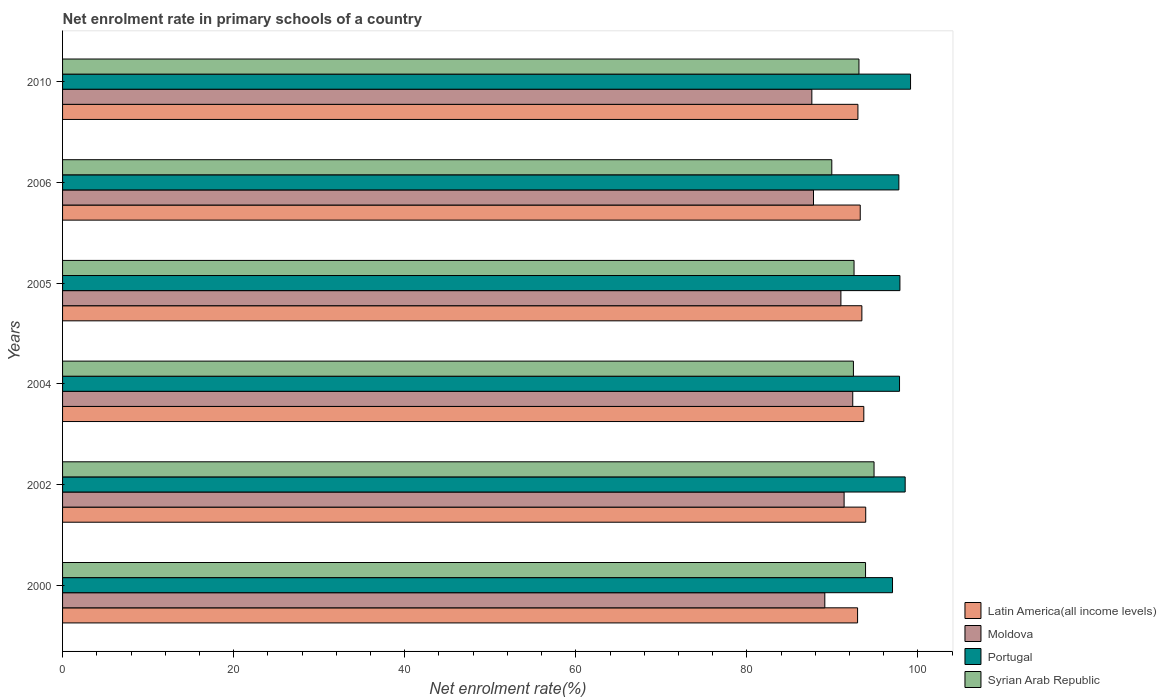Are the number of bars on each tick of the Y-axis equal?
Your response must be concise. Yes. How many bars are there on the 6th tick from the top?
Make the answer very short. 4. In how many cases, is the number of bars for a given year not equal to the number of legend labels?
Give a very brief answer. 0. What is the net enrolment rate in primary schools in Latin America(all income levels) in 2010?
Offer a very short reply. 92.98. Across all years, what is the maximum net enrolment rate in primary schools in Portugal?
Your answer should be very brief. 99.13. Across all years, what is the minimum net enrolment rate in primary schools in Portugal?
Your answer should be compact. 97.02. What is the total net enrolment rate in primary schools in Latin America(all income levels) in the graph?
Keep it short and to the point. 560.16. What is the difference between the net enrolment rate in primary schools in Portugal in 2002 and that in 2004?
Offer a very short reply. 0.66. What is the difference between the net enrolment rate in primary schools in Moldova in 2010 and the net enrolment rate in primary schools in Syrian Arab Republic in 2000?
Ensure brevity in your answer.  -6.28. What is the average net enrolment rate in primary schools in Portugal per year?
Give a very brief answer. 98.02. In the year 2000, what is the difference between the net enrolment rate in primary schools in Moldova and net enrolment rate in primary schools in Syrian Arab Republic?
Your answer should be very brief. -4.76. What is the ratio of the net enrolment rate in primary schools in Portugal in 2004 to that in 2010?
Provide a succinct answer. 0.99. Is the difference between the net enrolment rate in primary schools in Moldova in 2006 and 2010 greater than the difference between the net enrolment rate in primary schools in Syrian Arab Republic in 2006 and 2010?
Your answer should be very brief. Yes. What is the difference between the highest and the second highest net enrolment rate in primary schools in Latin America(all income levels)?
Provide a succinct answer. 0.22. What is the difference between the highest and the lowest net enrolment rate in primary schools in Latin America(all income levels)?
Provide a succinct answer. 0.95. In how many years, is the net enrolment rate in primary schools in Moldova greater than the average net enrolment rate in primary schools in Moldova taken over all years?
Ensure brevity in your answer.  3. What does the 4th bar from the top in 2004 represents?
Make the answer very short. Latin America(all income levels). What does the 2nd bar from the bottom in 2006 represents?
Give a very brief answer. Moldova. Is it the case that in every year, the sum of the net enrolment rate in primary schools in Portugal and net enrolment rate in primary schools in Syrian Arab Republic is greater than the net enrolment rate in primary schools in Moldova?
Provide a succinct answer. Yes. Are all the bars in the graph horizontal?
Give a very brief answer. Yes. How many years are there in the graph?
Offer a terse response. 6. What is the difference between two consecutive major ticks on the X-axis?
Your response must be concise. 20. Does the graph contain any zero values?
Provide a short and direct response. No. Does the graph contain grids?
Offer a very short reply. No. Where does the legend appear in the graph?
Offer a very short reply. Bottom right. How many legend labels are there?
Provide a succinct answer. 4. How are the legend labels stacked?
Offer a terse response. Vertical. What is the title of the graph?
Your response must be concise. Net enrolment rate in primary schools of a country. What is the label or title of the X-axis?
Offer a terse response. Net enrolment rate(%). What is the Net enrolment rate(%) of Latin America(all income levels) in 2000?
Keep it short and to the point. 92.94. What is the Net enrolment rate(%) of Moldova in 2000?
Your response must be concise. 89.11. What is the Net enrolment rate(%) in Portugal in 2000?
Offer a terse response. 97.02. What is the Net enrolment rate(%) of Syrian Arab Republic in 2000?
Offer a terse response. 93.87. What is the Net enrolment rate(%) in Latin America(all income levels) in 2002?
Your answer should be compact. 93.89. What is the Net enrolment rate(%) of Moldova in 2002?
Provide a succinct answer. 91.36. What is the Net enrolment rate(%) in Portugal in 2002?
Give a very brief answer. 98.5. What is the Net enrolment rate(%) in Syrian Arab Republic in 2002?
Your response must be concise. 94.86. What is the Net enrolment rate(%) of Latin America(all income levels) in 2004?
Make the answer very short. 93.67. What is the Net enrolment rate(%) in Moldova in 2004?
Keep it short and to the point. 92.37. What is the Net enrolment rate(%) of Portugal in 2004?
Ensure brevity in your answer.  97.84. What is the Net enrolment rate(%) in Syrian Arab Republic in 2004?
Your response must be concise. 92.45. What is the Net enrolment rate(%) of Latin America(all income levels) in 2005?
Your answer should be compact. 93.44. What is the Net enrolment rate(%) of Moldova in 2005?
Make the answer very short. 90.99. What is the Net enrolment rate(%) of Portugal in 2005?
Offer a terse response. 97.89. What is the Net enrolment rate(%) of Syrian Arab Republic in 2005?
Provide a succinct answer. 92.53. What is the Net enrolment rate(%) of Latin America(all income levels) in 2006?
Provide a short and direct response. 93.25. What is the Net enrolment rate(%) in Moldova in 2006?
Provide a succinct answer. 87.79. What is the Net enrolment rate(%) of Portugal in 2006?
Give a very brief answer. 97.76. What is the Net enrolment rate(%) of Syrian Arab Republic in 2006?
Make the answer very short. 89.92. What is the Net enrolment rate(%) of Latin America(all income levels) in 2010?
Your answer should be very brief. 92.98. What is the Net enrolment rate(%) in Moldova in 2010?
Provide a succinct answer. 87.59. What is the Net enrolment rate(%) of Portugal in 2010?
Your answer should be compact. 99.13. What is the Net enrolment rate(%) in Syrian Arab Republic in 2010?
Provide a succinct answer. 93.1. Across all years, what is the maximum Net enrolment rate(%) of Latin America(all income levels)?
Offer a very short reply. 93.89. Across all years, what is the maximum Net enrolment rate(%) in Moldova?
Your response must be concise. 92.37. Across all years, what is the maximum Net enrolment rate(%) in Portugal?
Provide a short and direct response. 99.13. Across all years, what is the maximum Net enrolment rate(%) of Syrian Arab Republic?
Provide a succinct answer. 94.86. Across all years, what is the minimum Net enrolment rate(%) in Latin America(all income levels)?
Offer a very short reply. 92.94. Across all years, what is the minimum Net enrolment rate(%) in Moldova?
Offer a very short reply. 87.59. Across all years, what is the minimum Net enrolment rate(%) of Portugal?
Ensure brevity in your answer.  97.02. Across all years, what is the minimum Net enrolment rate(%) in Syrian Arab Republic?
Provide a succinct answer. 89.92. What is the total Net enrolment rate(%) in Latin America(all income levels) in the graph?
Your response must be concise. 560.16. What is the total Net enrolment rate(%) in Moldova in the graph?
Keep it short and to the point. 539.21. What is the total Net enrolment rate(%) of Portugal in the graph?
Your answer should be very brief. 588.15. What is the total Net enrolment rate(%) of Syrian Arab Republic in the graph?
Your answer should be very brief. 556.73. What is the difference between the Net enrolment rate(%) of Latin America(all income levels) in 2000 and that in 2002?
Your answer should be compact. -0.95. What is the difference between the Net enrolment rate(%) in Moldova in 2000 and that in 2002?
Make the answer very short. -2.26. What is the difference between the Net enrolment rate(%) of Portugal in 2000 and that in 2002?
Provide a succinct answer. -1.48. What is the difference between the Net enrolment rate(%) of Syrian Arab Republic in 2000 and that in 2002?
Your answer should be compact. -0.99. What is the difference between the Net enrolment rate(%) in Latin America(all income levels) in 2000 and that in 2004?
Provide a short and direct response. -0.73. What is the difference between the Net enrolment rate(%) of Moldova in 2000 and that in 2004?
Provide a short and direct response. -3.27. What is the difference between the Net enrolment rate(%) of Portugal in 2000 and that in 2004?
Offer a terse response. -0.82. What is the difference between the Net enrolment rate(%) in Syrian Arab Republic in 2000 and that in 2004?
Provide a succinct answer. 1.42. What is the difference between the Net enrolment rate(%) of Latin America(all income levels) in 2000 and that in 2005?
Offer a very short reply. -0.5. What is the difference between the Net enrolment rate(%) of Moldova in 2000 and that in 2005?
Your answer should be very brief. -1.88. What is the difference between the Net enrolment rate(%) of Portugal in 2000 and that in 2005?
Your answer should be very brief. -0.87. What is the difference between the Net enrolment rate(%) of Syrian Arab Republic in 2000 and that in 2005?
Give a very brief answer. 1.35. What is the difference between the Net enrolment rate(%) of Latin America(all income levels) in 2000 and that in 2006?
Your response must be concise. -0.31. What is the difference between the Net enrolment rate(%) in Moldova in 2000 and that in 2006?
Ensure brevity in your answer.  1.32. What is the difference between the Net enrolment rate(%) of Portugal in 2000 and that in 2006?
Offer a very short reply. -0.74. What is the difference between the Net enrolment rate(%) in Syrian Arab Republic in 2000 and that in 2006?
Offer a very short reply. 3.95. What is the difference between the Net enrolment rate(%) of Latin America(all income levels) in 2000 and that in 2010?
Ensure brevity in your answer.  -0.04. What is the difference between the Net enrolment rate(%) of Moldova in 2000 and that in 2010?
Provide a succinct answer. 1.52. What is the difference between the Net enrolment rate(%) in Portugal in 2000 and that in 2010?
Offer a very short reply. -2.11. What is the difference between the Net enrolment rate(%) in Syrian Arab Republic in 2000 and that in 2010?
Keep it short and to the point. 0.77. What is the difference between the Net enrolment rate(%) of Latin America(all income levels) in 2002 and that in 2004?
Keep it short and to the point. 0.22. What is the difference between the Net enrolment rate(%) of Moldova in 2002 and that in 2004?
Provide a succinct answer. -1.01. What is the difference between the Net enrolment rate(%) of Portugal in 2002 and that in 2004?
Your answer should be very brief. 0.66. What is the difference between the Net enrolment rate(%) in Syrian Arab Republic in 2002 and that in 2004?
Your answer should be very brief. 2.41. What is the difference between the Net enrolment rate(%) of Latin America(all income levels) in 2002 and that in 2005?
Give a very brief answer. 0.45. What is the difference between the Net enrolment rate(%) in Moldova in 2002 and that in 2005?
Your response must be concise. 0.37. What is the difference between the Net enrolment rate(%) of Portugal in 2002 and that in 2005?
Offer a terse response. 0.61. What is the difference between the Net enrolment rate(%) in Syrian Arab Republic in 2002 and that in 2005?
Keep it short and to the point. 2.34. What is the difference between the Net enrolment rate(%) in Latin America(all income levels) in 2002 and that in 2006?
Ensure brevity in your answer.  0.64. What is the difference between the Net enrolment rate(%) in Moldova in 2002 and that in 2006?
Ensure brevity in your answer.  3.58. What is the difference between the Net enrolment rate(%) of Portugal in 2002 and that in 2006?
Provide a succinct answer. 0.74. What is the difference between the Net enrolment rate(%) of Syrian Arab Republic in 2002 and that in 2006?
Make the answer very short. 4.94. What is the difference between the Net enrolment rate(%) of Latin America(all income levels) in 2002 and that in 2010?
Your answer should be very brief. 0.91. What is the difference between the Net enrolment rate(%) of Moldova in 2002 and that in 2010?
Ensure brevity in your answer.  3.77. What is the difference between the Net enrolment rate(%) of Portugal in 2002 and that in 2010?
Your answer should be compact. -0.63. What is the difference between the Net enrolment rate(%) in Syrian Arab Republic in 2002 and that in 2010?
Provide a succinct answer. 1.77. What is the difference between the Net enrolment rate(%) of Latin America(all income levels) in 2004 and that in 2005?
Provide a short and direct response. 0.23. What is the difference between the Net enrolment rate(%) in Moldova in 2004 and that in 2005?
Ensure brevity in your answer.  1.38. What is the difference between the Net enrolment rate(%) of Portugal in 2004 and that in 2005?
Provide a succinct answer. -0.05. What is the difference between the Net enrolment rate(%) of Syrian Arab Republic in 2004 and that in 2005?
Ensure brevity in your answer.  -0.07. What is the difference between the Net enrolment rate(%) in Latin America(all income levels) in 2004 and that in 2006?
Give a very brief answer. 0.42. What is the difference between the Net enrolment rate(%) in Moldova in 2004 and that in 2006?
Provide a succinct answer. 4.59. What is the difference between the Net enrolment rate(%) in Portugal in 2004 and that in 2006?
Offer a terse response. 0.08. What is the difference between the Net enrolment rate(%) of Syrian Arab Republic in 2004 and that in 2006?
Keep it short and to the point. 2.53. What is the difference between the Net enrolment rate(%) in Latin America(all income levels) in 2004 and that in 2010?
Give a very brief answer. 0.69. What is the difference between the Net enrolment rate(%) in Moldova in 2004 and that in 2010?
Give a very brief answer. 4.78. What is the difference between the Net enrolment rate(%) of Portugal in 2004 and that in 2010?
Keep it short and to the point. -1.29. What is the difference between the Net enrolment rate(%) in Syrian Arab Republic in 2004 and that in 2010?
Offer a terse response. -0.65. What is the difference between the Net enrolment rate(%) of Latin America(all income levels) in 2005 and that in 2006?
Your answer should be compact. 0.19. What is the difference between the Net enrolment rate(%) in Moldova in 2005 and that in 2006?
Provide a short and direct response. 3.2. What is the difference between the Net enrolment rate(%) in Portugal in 2005 and that in 2006?
Your answer should be compact. 0.12. What is the difference between the Net enrolment rate(%) of Syrian Arab Republic in 2005 and that in 2006?
Make the answer very short. 2.6. What is the difference between the Net enrolment rate(%) of Latin America(all income levels) in 2005 and that in 2010?
Offer a very short reply. 0.46. What is the difference between the Net enrolment rate(%) of Moldova in 2005 and that in 2010?
Keep it short and to the point. 3.4. What is the difference between the Net enrolment rate(%) in Portugal in 2005 and that in 2010?
Your answer should be very brief. -1.24. What is the difference between the Net enrolment rate(%) of Syrian Arab Republic in 2005 and that in 2010?
Make the answer very short. -0.57. What is the difference between the Net enrolment rate(%) in Latin America(all income levels) in 2006 and that in 2010?
Ensure brevity in your answer.  0.27. What is the difference between the Net enrolment rate(%) of Moldova in 2006 and that in 2010?
Ensure brevity in your answer.  0.19. What is the difference between the Net enrolment rate(%) of Portugal in 2006 and that in 2010?
Offer a very short reply. -1.37. What is the difference between the Net enrolment rate(%) of Syrian Arab Republic in 2006 and that in 2010?
Offer a very short reply. -3.17. What is the difference between the Net enrolment rate(%) in Latin America(all income levels) in 2000 and the Net enrolment rate(%) in Moldova in 2002?
Offer a very short reply. 1.57. What is the difference between the Net enrolment rate(%) of Latin America(all income levels) in 2000 and the Net enrolment rate(%) of Portugal in 2002?
Your response must be concise. -5.56. What is the difference between the Net enrolment rate(%) in Latin America(all income levels) in 2000 and the Net enrolment rate(%) in Syrian Arab Republic in 2002?
Give a very brief answer. -1.93. What is the difference between the Net enrolment rate(%) of Moldova in 2000 and the Net enrolment rate(%) of Portugal in 2002?
Make the answer very short. -9.39. What is the difference between the Net enrolment rate(%) in Moldova in 2000 and the Net enrolment rate(%) in Syrian Arab Republic in 2002?
Your answer should be compact. -5.76. What is the difference between the Net enrolment rate(%) of Portugal in 2000 and the Net enrolment rate(%) of Syrian Arab Republic in 2002?
Give a very brief answer. 2.16. What is the difference between the Net enrolment rate(%) in Latin America(all income levels) in 2000 and the Net enrolment rate(%) in Moldova in 2004?
Provide a succinct answer. 0.56. What is the difference between the Net enrolment rate(%) in Latin America(all income levels) in 2000 and the Net enrolment rate(%) in Portugal in 2004?
Your response must be concise. -4.9. What is the difference between the Net enrolment rate(%) of Latin America(all income levels) in 2000 and the Net enrolment rate(%) of Syrian Arab Republic in 2004?
Your answer should be very brief. 0.49. What is the difference between the Net enrolment rate(%) of Moldova in 2000 and the Net enrolment rate(%) of Portugal in 2004?
Offer a very short reply. -8.73. What is the difference between the Net enrolment rate(%) of Moldova in 2000 and the Net enrolment rate(%) of Syrian Arab Republic in 2004?
Your response must be concise. -3.34. What is the difference between the Net enrolment rate(%) of Portugal in 2000 and the Net enrolment rate(%) of Syrian Arab Republic in 2004?
Offer a very short reply. 4.57. What is the difference between the Net enrolment rate(%) of Latin America(all income levels) in 2000 and the Net enrolment rate(%) of Moldova in 2005?
Your answer should be compact. 1.95. What is the difference between the Net enrolment rate(%) in Latin America(all income levels) in 2000 and the Net enrolment rate(%) in Portugal in 2005?
Provide a short and direct response. -4.95. What is the difference between the Net enrolment rate(%) of Latin America(all income levels) in 2000 and the Net enrolment rate(%) of Syrian Arab Republic in 2005?
Make the answer very short. 0.41. What is the difference between the Net enrolment rate(%) of Moldova in 2000 and the Net enrolment rate(%) of Portugal in 2005?
Give a very brief answer. -8.78. What is the difference between the Net enrolment rate(%) in Moldova in 2000 and the Net enrolment rate(%) in Syrian Arab Republic in 2005?
Keep it short and to the point. -3.42. What is the difference between the Net enrolment rate(%) of Portugal in 2000 and the Net enrolment rate(%) of Syrian Arab Republic in 2005?
Your response must be concise. 4.5. What is the difference between the Net enrolment rate(%) in Latin America(all income levels) in 2000 and the Net enrolment rate(%) in Moldova in 2006?
Your response must be concise. 5.15. What is the difference between the Net enrolment rate(%) of Latin America(all income levels) in 2000 and the Net enrolment rate(%) of Portugal in 2006?
Give a very brief answer. -4.83. What is the difference between the Net enrolment rate(%) of Latin America(all income levels) in 2000 and the Net enrolment rate(%) of Syrian Arab Republic in 2006?
Your response must be concise. 3.01. What is the difference between the Net enrolment rate(%) in Moldova in 2000 and the Net enrolment rate(%) in Portugal in 2006?
Give a very brief answer. -8.66. What is the difference between the Net enrolment rate(%) of Moldova in 2000 and the Net enrolment rate(%) of Syrian Arab Republic in 2006?
Your answer should be compact. -0.82. What is the difference between the Net enrolment rate(%) in Portugal in 2000 and the Net enrolment rate(%) in Syrian Arab Republic in 2006?
Your answer should be very brief. 7.1. What is the difference between the Net enrolment rate(%) in Latin America(all income levels) in 2000 and the Net enrolment rate(%) in Moldova in 2010?
Make the answer very short. 5.35. What is the difference between the Net enrolment rate(%) in Latin America(all income levels) in 2000 and the Net enrolment rate(%) in Portugal in 2010?
Make the answer very short. -6.19. What is the difference between the Net enrolment rate(%) in Latin America(all income levels) in 2000 and the Net enrolment rate(%) in Syrian Arab Republic in 2010?
Your response must be concise. -0.16. What is the difference between the Net enrolment rate(%) of Moldova in 2000 and the Net enrolment rate(%) of Portugal in 2010?
Your answer should be compact. -10.02. What is the difference between the Net enrolment rate(%) of Moldova in 2000 and the Net enrolment rate(%) of Syrian Arab Republic in 2010?
Your response must be concise. -3.99. What is the difference between the Net enrolment rate(%) of Portugal in 2000 and the Net enrolment rate(%) of Syrian Arab Republic in 2010?
Offer a very short reply. 3.92. What is the difference between the Net enrolment rate(%) of Latin America(all income levels) in 2002 and the Net enrolment rate(%) of Moldova in 2004?
Provide a succinct answer. 1.52. What is the difference between the Net enrolment rate(%) in Latin America(all income levels) in 2002 and the Net enrolment rate(%) in Portugal in 2004?
Your answer should be very brief. -3.95. What is the difference between the Net enrolment rate(%) of Latin America(all income levels) in 2002 and the Net enrolment rate(%) of Syrian Arab Republic in 2004?
Ensure brevity in your answer.  1.44. What is the difference between the Net enrolment rate(%) in Moldova in 2002 and the Net enrolment rate(%) in Portugal in 2004?
Your answer should be compact. -6.48. What is the difference between the Net enrolment rate(%) of Moldova in 2002 and the Net enrolment rate(%) of Syrian Arab Republic in 2004?
Give a very brief answer. -1.09. What is the difference between the Net enrolment rate(%) in Portugal in 2002 and the Net enrolment rate(%) in Syrian Arab Republic in 2004?
Your response must be concise. 6.05. What is the difference between the Net enrolment rate(%) in Latin America(all income levels) in 2002 and the Net enrolment rate(%) in Moldova in 2005?
Offer a terse response. 2.9. What is the difference between the Net enrolment rate(%) of Latin America(all income levels) in 2002 and the Net enrolment rate(%) of Portugal in 2005?
Make the answer very short. -4. What is the difference between the Net enrolment rate(%) in Latin America(all income levels) in 2002 and the Net enrolment rate(%) in Syrian Arab Republic in 2005?
Provide a short and direct response. 1.36. What is the difference between the Net enrolment rate(%) in Moldova in 2002 and the Net enrolment rate(%) in Portugal in 2005?
Provide a succinct answer. -6.52. What is the difference between the Net enrolment rate(%) in Moldova in 2002 and the Net enrolment rate(%) in Syrian Arab Republic in 2005?
Offer a terse response. -1.16. What is the difference between the Net enrolment rate(%) of Portugal in 2002 and the Net enrolment rate(%) of Syrian Arab Republic in 2005?
Your answer should be very brief. 5.98. What is the difference between the Net enrolment rate(%) in Latin America(all income levels) in 2002 and the Net enrolment rate(%) in Moldova in 2006?
Offer a terse response. 6.1. What is the difference between the Net enrolment rate(%) of Latin America(all income levels) in 2002 and the Net enrolment rate(%) of Portugal in 2006?
Ensure brevity in your answer.  -3.87. What is the difference between the Net enrolment rate(%) of Latin America(all income levels) in 2002 and the Net enrolment rate(%) of Syrian Arab Republic in 2006?
Offer a very short reply. 3.97. What is the difference between the Net enrolment rate(%) of Moldova in 2002 and the Net enrolment rate(%) of Portugal in 2006?
Make the answer very short. -6.4. What is the difference between the Net enrolment rate(%) of Moldova in 2002 and the Net enrolment rate(%) of Syrian Arab Republic in 2006?
Give a very brief answer. 1.44. What is the difference between the Net enrolment rate(%) in Portugal in 2002 and the Net enrolment rate(%) in Syrian Arab Republic in 2006?
Your answer should be compact. 8.58. What is the difference between the Net enrolment rate(%) in Latin America(all income levels) in 2002 and the Net enrolment rate(%) in Moldova in 2010?
Your answer should be very brief. 6.3. What is the difference between the Net enrolment rate(%) of Latin America(all income levels) in 2002 and the Net enrolment rate(%) of Portugal in 2010?
Your answer should be very brief. -5.24. What is the difference between the Net enrolment rate(%) in Latin America(all income levels) in 2002 and the Net enrolment rate(%) in Syrian Arab Republic in 2010?
Provide a short and direct response. 0.79. What is the difference between the Net enrolment rate(%) of Moldova in 2002 and the Net enrolment rate(%) of Portugal in 2010?
Offer a terse response. -7.77. What is the difference between the Net enrolment rate(%) in Moldova in 2002 and the Net enrolment rate(%) in Syrian Arab Republic in 2010?
Ensure brevity in your answer.  -1.73. What is the difference between the Net enrolment rate(%) of Portugal in 2002 and the Net enrolment rate(%) of Syrian Arab Republic in 2010?
Give a very brief answer. 5.4. What is the difference between the Net enrolment rate(%) of Latin America(all income levels) in 2004 and the Net enrolment rate(%) of Moldova in 2005?
Provide a succinct answer. 2.68. What is the difference between the Net enrolment rate(%) of Latin America(all income levels) in 2004 and the Net enrolment rate(%) of Portugal in 2005?
Give a very brief answer. -4.22. What is the difference between the Net enrolment rate(%) in Latin America(all income levels) in 2004 and the Net enrolment rate(%) in Syrian Arab Republic in 2005?
Provide a short and direct response. 1.14. What is the difference between the Net enrolment rate(%) of Moldova in 2004 and the Net enrolment rate(%) of Portugal in 2005?
Offer a terse response. -5.51. What is the difference between the Net enrolment rate(%) in Moldova in 2004 and the Net enrolment rate(%) in Syrian Arab Republic in 2005?
Make the answer very short. -0.15. What is the difference between the Net enrolment rate(%) in Portugal in 2004 and the Net enrolment rate(%) in Syrian Arab Republic in 2005?
Keep it short and to the point. 5.32. What is the difference between the Net enrolment rate(%) in Latin America(all income levels) in 2004 and the Net enrolment rate(%) in Moldova in 2006?
Offer a very short reply. 5.88. What is the difference between the Net enrolment rate(%) of Latin America(all income levels) in 2004 and the Net enrolment rate(%) of Portugal in 2006?
Ensure brevity in your answer.  -4.1. What is the difference between the Net enrolment rate(%) in Latin America(all income levels) in 2004 and the Net enrolment rate(%) in Syrian Arab Republic in 2006?
Your response must be concise. 3.74. What is the difference between the Net enrolment rate(%) of Moldova in 2004 and the Net enrolment rate(%) of Portugal in 2006?
Offer a terse response. -5.39. What is the difference between the Net enrolment rate(%) of Moldova in 2004 and the Net enrolment rate(%) of Syrian Arab Republic in 2006?
Keep it short and to the point. 2.45. What is the difference between the Net enrolment rate(%) of Portugal in 2004 and the Net enrolment rate(%) of Syrian Arab Republic in 2006?
Provide a short and direct response. 7.92. What is the difference between the Net enrolment rate(%) of Latin America(all income levels) in 2004 and the Net enrolment rate(%) of Moldova in 2010?
Make the answer very short. 6.08. What is the difference between the Net enrolment rate(%) of Latin America(all income levels) in 2004 and the Net enrolment rate(%) of Portugal in 2010?
Offer a very short reply. -5.46. What is the difference between the Net enrolment rate(%) in Latin America(all income levels) in 2004 and the Net enrolment rate(%) in Syrian Arab Republic in 2010?
Offer a very short reply. 0.57. What is the difference between the Net enrolment rate(%) of Moldova in 2004 and the Net enrolment rate(%) of Portugal in 2010?
Provide a succinct answer. -6.76. What is the difference between the Net enrolment rate(%) in Moldova in 2004 and the Net enrolment rate(%) in Syrian Arab Republic in 2010?
Provide a short and direct response. -0.72. What is the difference between the Net enrolment rate(%) in Portugal in 2004 and the Net enrolment rate(%) in Syrian Arab Republic in 2010?
Your answer should be very brief. 4.74. What is the difference between the Net enrolment rate(%) in Latin America(all income levels) in 2005 and the Net enrolment rate(%) in Moldova in 2006?
Your answer should be very brief. 5.66. What is the difference between the Net enrolment rate(%) in Latin America(all income levels) in 2005 and the Net enrolment rate(%) in Portugal in 2006?
Offer a very short reply. -4.32. What is the difference between the Net enrolment rate(%) of Latin America(all income levels) in 2005 and the Net enrolment rate(%) of Syrian Arab Republic in 2006?
Your answer should be very brief. 3.52. What is the difference between the Net enrolment rate(%) in Moldova in 2005 and the Net enrolment rate(%) in Portugal in 2006?
Provide a succinct answer. -6.77. What is the difference between the Net enrolment rate(%) of Moldova in 2005 and the Net enrolment rate(%) of Syrian Arab Republic in 2006?
Offer a terse response. 1.07. What is the difference between the Net enrolment rate(%) in Portugal in 2005 and the Net enrolment rate(%) in Syrian Arab Republic in 2006?
Offer a very short reply. 7.96. What is the difference between the Net enrolment rate(%) of Latin America(all income levels) in 2005 and the Net enrolment rate(%) of Moldova in 2010?
Ensure brevity in your answer.  5.85. What is the difference between the Net enrolment rate(%) in Latin America(all income levels) in 2005 and the Net enrolment rate(%) in Portugal in 2010?
Give a very brief answer. -5.69. What is the difference between the Net enrolment rate(%) in Latin America(all income levels) in 2005 and the Net enrolment rate(%) in Syrian Arab Republic in 2010?
Keep it short and to the point. 0.34. What is the difference between the Net enrolment rate(%) of Moldova in 2005 and the Net enrolment rate(%) of Portugal in 2010?
Your response must be concise. -8.14. What is the difference between the Net enrolment rate(%) in Moldova in 2005 and the Net enrolment rate(%) in Syrian Arab Republic in 2010?
Offer a terse response. -2.11. What is the difference between the Net enrolment rate(%) of Portugal in 2005 and the Net enrolment rate(%) of Syrian Arab Republic in 2010?
Your answer should be very brief. 4.79. What is the difference between the Net enrolment rate(%) in Latin America(all income levels) in 2006 and the Net enrolment rate(%) in Moldova in 2010?
Keep it short and to the point. 5.66. What is the difference between the Net enrolment rate(%) in Latin America(all income levels) in 2006 and the Net enrolment rate(%) in Portugal in 2010?
Provide a short and direct response. -5.88. What is the difference between the Net enrolment rate(%) in Latin America(all income levels) in 2006 and the Net enrolment rate(%) in Syrian Arab Republic in 2010?
Your answer should be very brief. 0.15. What is the difference between the Net enrolment rate(%) in Moldova in 2006 and the Net enrolment rate(%) in Portugal in 2010?
Your answer should be very brief. -11.34. What is the difference between the Net enrolment rate(%) of Moldova in 2006 and the Net enrolment rate(%) of Syrian Arab Republic in 2010?
Provide a succinct answer. -5.31. What is the difference between the Net enrolment rate(%) in Portugal in 2006 and the Net enrolment rate(%) in Syrian Arab Republic in 2010?
Keep it short and to the point. 4.67. What is the average Net enrolment rate(%) in Latin America(all income levels) per year?
Your response must be concise. 93.36. What is the average Net enrolment rate(%) in Moldova per year?
Make the answer very short. 89.87. What is the average Net enrolment rate(%) of Portugal per year?
Give a very brief answer. 98.02. What is the average Net enrolment rate(%) in Syrian Arab Republic per year?
Provide a short and direct response. 92.79. In the year 2000, what is the difference between the Net enrolment rate(%) in Latin America(all income levels) and Net enrolment rate(%) in Moldova?
Keep it short and to the point. 3.83. In the year 2000, what is the difference between the Net enrolment rate(%) in Latin America(all income levels) and Net enrolment rate(%) in Portugal?
Offer a terse response. -4.09. In the year 2000, what is the difference between the Net enrolment rate(%) in Latin America(all income levels) and Net enrolment rate(%) in Syrian Arab Republic?
Provide a succinct answer. -0.93. In the year 2000, what is the difference between the Net enrolment rate(%) of Moldova and Net enrolment rate(%) of Portugal?
Give a very brief answer. -7.91. In the year 2000, what is the difference between the Net enrolment rate(%) in Moldova and Net enrolment rate(%) in Syrian Arab Republic?
Offer a terse response. -4.76. In the year 2000, what is the difference between the Net enrolment rate(%) in Portugal and Net enrolment rate(%) in Syrian Arab Republic?
Give a very brief answer. 3.15. In the year 2002, what is the difference between the Net enrolment rate(%) in Latin America(all income levels) and Net enrolment rate(%) in Moldova?
Keep it short and to the point. 2.53. In the year 2002, what is the difference between the Net enrolment rate(%) of Latin America(all income levels) and Net enrolment rate(%) of Portugal?
Provide a succinct answer. -4.61. In the year 2002, what is the difference between the Net enrolment rate(%) of Latin America(all income levels) and Net enrolment rate(%) of Syrian Arab Republic?
Offer a terse response. -0.97. In the year 2002, what is the difference between the Net enrolment rate(%) in Moldova and Net enrolment rate(%) in Portugal?
Your answer should be compact. -7.14. In the year 2002, what is the difference between the Net enrolment rate(%) of Moldova and Net enrolment rate(%) of Syrian Arab Republic?
Make the answer very short. -3.5. In the year 2002, what is the difference between the Net enrolment rate(%) of Portugal and Net enrolment rate(%) of Syrian Arab Republic?
Offer a terse response. 3.64. In the year 2004, what is the difference between the Net enrolment rate(%) in Latin America(all income levels) and Net enrolment rate(%) in Moldova?
Give a very brief answer. 1.29. In the year 2004, what is the difference between the Net enrolment rate(%) in Latin America(all income levels) and Net enrolment rate(%) in Portugal?
Your answer should be very brief. -4.17. In the year 2004, what is the difference between the Net enrolment rate(%) in Latin America(all income levels) and Net enrolment rate(%) in Syrian Arab Republic?
Your answer should be compact. 1.22. In the year 2004, what is the difference between the Net enrolment rate(%) of Moldova and Net enrolment rate(%) of Portugal?
Make the answer very short. -5.47. In the year 2004, what is the difference between the Net enrolment rate(%) in Moldova and Net enrolment rate(%) in Syrian Arab Republic?
Keep it short and to the point. -0.08. In the year 2004, what is the difference between the Net enrolment rate(%) of Portugal and Net enrolment rate(%) of Syrian Arab Republic?
Keep it short and to the point. 5.39. In the year 2005, what is the difference between the Net enrolment rate(%) of Latin America(all income levels) and Net enrolment rate(%) of Moldova?
Offer a very short reply. 2.45. In the year 2005, what is the difference between the Net enrolment rate(%) of Latin America(all income levels) and Net enrolment rate(%) of Portugal?
Provide a short and direct response. -4.45. In the year 2005, what is the difference between the Net enrolment rate(%) in Latin America(all income levels) and Net enrolment rate(%) in Syrian Arab Republic?
Make the answer very short. 0.92. In the year 2005, what is the difference between the Net enrolment rate(%) in Moldova and Net enrolment rate(%) in Portugal?
Offer a very short reply. -6.9. In the year 2005, what is the difference between the Net enrolment rate(%) in Moldova and Net enrolment rate(%) in Syrian Arab Republic?
Make the answer very short. -1.54. In the year 2005, what is the difference between the Net enrolment rate(%) of Portugal and Net enrolment rate(%) of Syrian Arab Republic?
Make the answer very short. 5.36. In the year 2006, what is the difference between the Net enrolment rate(%) of Latin America(all income levels) and Net enrolment rate(%) of Moldova?
Your answer should be compact. 5.46. In the year 2006, what is the difference between the Net enrolment rate(%) in Latin America(all income levels) and Net enrolment rate(%) in Portugal?
Offer a terse response. -4.51. In the year 2006, what is the difference between the Net enrolment rate(%) in Latin America(all income levels) and Net enrolment rate(%) in Syrian Arab Republic?
Your answer should be very brief. 3.32. In the year 2006, what is the difference between the Net enrolment rate(%) of Moldova and Net enrolment rate(%) of Portugal?
Offer a terse response. -9.98. In the year 2006, what is the difference between the Net enrolment rate(%) in Moldova and Net enrolment rate(%) in Syrian Arab Republic?
Give a very brief answer. -2.14. In the year 2006, what is the difference between the Net enrolment rate(%) of Portugal and Net enrolment rate(%) of Syrian Arab Republic?
Your answer should be compact. 7.84. In the year 2010, what is the difference between the Net enrolment rate(%) of Latin America(all income levels) and Net enrolment rate(%) of Moldova?
Your response must be concise. 5.39. In the year 2010, what is the difference between the Net enrolment rate(%) of Latin America(all income levels) and Net enrolment rate(%) of Portugal?
Keep it short and to the point. -6.15. In the year 2010, what is the difference between the Net enrolment rate(%) in Latin America(all income levels) and Net enrolment rate(%) in Syrian Arab Republic?
Make the answer very short. -0.12. In the year 2010, what is the difference between the Net enrolment rate(%) in Moldova and Net enrolment rate(%) in Portugal?
Your response must be concise. -11.54. In the year 2010, what is the difference between the Net enrolment rate(%) in Moldova and Net enrolment rate(%) in Syrian Arab Republic?
Your answer should be compact. -5.51. In the year 2010, what is the difference between the Net enrolment rate(%) of Portugal and Net enrolment rate(%) of Syrian Arab Republic?
Ensure brevity in your answer.  6.03. What is the ratio of the Net enrolment rate(%) of Moldova in 2000 to that in 2002?
Offer a very short reply. 0.98. What is the ratio of the Net enrolment rate(%) of Moldova in 2000 to that in 2004?
Your answer should be compact. 0.96. What is the ratio of the Net enrolment rate(%) in Syrian Arab Republic in 2000 to that in 2004?
Ensure brevity in your answer.  1.02. What is the ratio of the Net enrolment rate(%) of Latin America(all income levels) in 2000 to that in 2005?
Your response must be concise. 0.99. What is the ratio of the Net enrolment rate(%) of Moldova in 2000 to that in 2005?
Provide a short and direct response. 0.98. What is the ratio of the Net enrolment rate(%) in Portugal in 2000 to that in 2005?
Keep it short and to the point. 0.99. What is the ratio of the Net enrolment rate(%) in Syrian Arab Republic in 2000 to that in 2005?
Give a very brief answer. 1.01. What is the ratio of the Net enrolment rate(%) of Moldova in 2000 to that in 2006?
Keep it short and to the point. 1.02. What is the ratio of the Net enrolment rate(%) of Portugal in 2000 to that in 2006?
Give a very brief answer. 0.99. What is the ratio of the Net enrolment rate(%) of Syrian Arab Republic in 2000 to that in 2006?
Your answer should be very brief. 1.04. What is the ratio of the Net enrolment rate(%) in Latin America(all income levels) in 2000 to that in 2010?
Your response must be concise. 1. What is the ratio of the Net enrolment rate(%) in Moldova in 2000 to that in 2010?
Make the answer very short. 1.02. What is the ratio of the Net enrolment rate(%) in Portugal in 2000 to that in 2010?
Ensure brevity in your answer.  0.98. What is the ratio of the Net enrolment rate(%) in Syrian Arab Republic in 2000 to that in 2010?
Offer a very short reply. 1.01. What is the ratio of the Net enrolment rate(%) in Latin America(all income levels) in 2002 to that in 2004?
Ensure brevity in your answer.  1. What is the ratio of the Net enrolment rate(%) in Syrian Arab Republic in 2002 to that in 2004?
Give a very brief answer. 1.03. What is the ratio of the Net enrolment rate(%) of Moldova in 2002 to that in 2005?
Your answer should be compact. 1. What is the ratio of the Net enrolment rate(%) of Syrian Arab Republic in 2002 to that in 2005?
Give a very brief answer. 1.03. What is the ratio of the Net enrolment rate(%) in Moldova in 2002 to that in 2006?
Your answer should be compact. 1.04. What is the ratio of the Net enrolment rate(%) of Portugal in 2002 to that in 2006?
Your response must be concise. 1.01. What is the ratio of the Net enrolment rate(%) of Syrian Arab Republic in 2002 to that in 2006?
Provide a short and direct response. 1.05. What is the ratio of the Net enrolment rate(%) in Latin America(all income levels) in 2002 to that in 2010?
Your answer should be very brief. 1.01. What is the ratio of the Net enrolment rate(%) of Moldova in 2002 to that in 2010?
Make the answer very short. 1.04. What is the ratio of the Net enrolment rate(%) in Syrian Arab Republic in 2002 to that in 2010?
Your response must be concise. 1.02. What is the ratio of the Net enrolment rate(%) in Latin America(all income levels) in 2004 to that in 2005?
Offer a terse response. 1. What is the ratio of the Net enrolment rate(%) in Moldova in 2004 to that in 2005?
Provide a succinct answer. 1.02. What is the ratio of the Net enrolment rate(%) in Portugal in 2004 to that in 2005?
Your answer should be compact. 1. What is the ratio of the Net enrolment rate(%) in Moldova in 2004 to that in 2006?
Provide a short and direct response. 1.05. What is the ratio of the Net enrolment rate(%) of Portugal in 2004 to that in 2006?
Your answer should be compact. 1. What is the ratio of the Net enrolment rate(%) of Syrian Arab Republic in 2004 to that in 2006?
Ensure brevity in your answer.  1.03. What is the ratio of the Net enrolment rate(%) of Latin America(all income levels) in 2004 to that in 2010?
Keep it short and to the point. 1.01. What is the ratio of the Net enrolment rate(%) of Moldova in 2004 to that in 2010?
Make the answer very short. 1.05. What is the ratio of the Net enrolment rate(%) in Portugal in 2004 to that in 2010?
Provide a short and direct response. 0.99. What is the ratio of the Net enrolment rate(%) in Syrian Arab Republic in 2004 to that in 2010?
Offer a very short reply. 0.99. What is the ratio of the Net enrolment rate(%) of Moldova in 2005 to that in 2006?
Provide a succinct answer. 1.04. What is the ratio of the Net enrolment rate(%) in Portugal in 2005 to that in 2006?
Your answer should be very brief. 1. What is the ratio of the Net enrolment rate(%) of Syrian Arab Republic in 2005 to that in 2006?
Provide a short and direct response. 1.03. What is the ratio of the Net enrolment rate(%) of Moldova in 2005 to that in 2010?
Offer a terse response. 1.04. What is the ratio of the Net enrolment rate(%) in Portugal in 2005 to that in 2010?
Offer a terse response. 0.99. What is the ratio of the Net enrolment rate(%) of Moldova in 2006 to that in 2010?
Ensure brevity in your answer.  1. What is the ratio of the Net enrolment rate(%) in Portugal in 2006 to that in 2010?
Offer a terse response. 0.99. What is the ratio of the Net enrolment rate(%) in Syrian Arab Republic in 2006 to that in 2010?
Keep it short and to the point. 0.97. What is the difference between the highest and the second highest Net enrolment rate(%) of Latin America(all income levels)?
Ensure brevity in your answer.  0.22. What is the difference between the highest and the second highest Net enrolment rate(%) in Portugal?
Ensure brevity in your answer.  0.63. What is the difference between the highest and the second highest Net enrolment rate(%) in Syrian Arab Republic?
Provide a succinct answer. 0.99. What is the difference between the highest and the lowest Net enrolment rate(%) in Latin America(all income levels)?
Offer a very short reply. 0.95. What is the difference between the highest and the lowest Net enrolment rate(%) in Moldova?
Offer a very short reply. 4.78. What is the difference between the highest and the lowest Net enrolment rate(%) in Portugal?
Your response must be concise. 2.11. What is the difference between the highest and the lowest Net enrolment rate(%) of Syrian Arab Republic?
Keep it short and to the point. 4.94. 